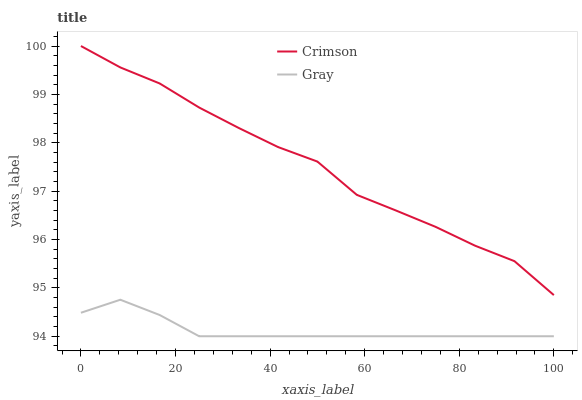Does Gray have the minimum area under the curve?
Answer yes or no. Yes. Does Crimson have the maximum area under the curve?
Answer yes or no. Yes. Does Gray have the maximum area under the curve?
Answer yes or no. No. Is Gray the smoothest?
Answer yes or no. Yes. Is Crimson the roughest?
Answer yes or no. Yes. Is Gray the roughest?
Answer yes or no. No. Does Crimson have the highest value?
Answer yes or no. Yes. Does Gray have the highest value?
Answer yes or no. No. Is Gray less than Crimson?
Answer yes or no. Yes. Is Crimson greater than Gray?
Answer yes or no. Yes. Does Gray intersect Crimson?
Answer yes or no. No. 